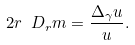<formula> <loc_0><loc_0><loc_500><loc_500>2 r \ D _ { r } m = \frac { \Delta _ { \gamma } u } { u } .</formula> 